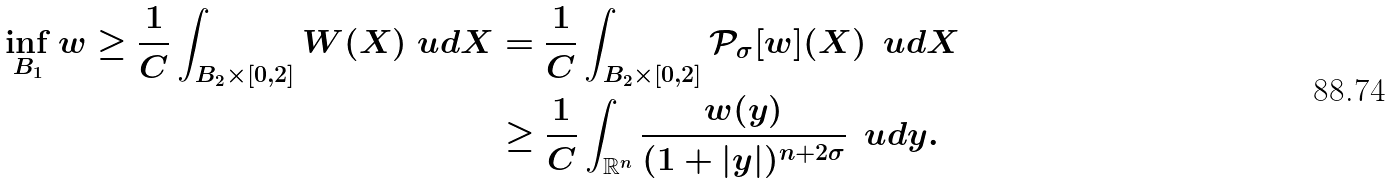Convert formula to latex. <formula><loc_0><loc_0><loc_500><loc_500>\inf _ { B _ { 1 } } w \geq \frac { 1 } { C } \int _ { B _ { 2 } \times [ 0 , 2 ] } W ( X ) \ u d X & = \frac { 1 } { C } \int _ { B _ { 2 } \times [ 0 , 2 ] } \mathcal { P } _ { \sigma } [ w ] ( X ) \, \ u d X \\ & \geq \frac { 1 } { C } \int _ { \mathbb { R } ^ { n } } \frac { w ( y ) } { ( 1 + | y | ) ^ { n + 2 \sigma } } \, \ u d y .</formula> 